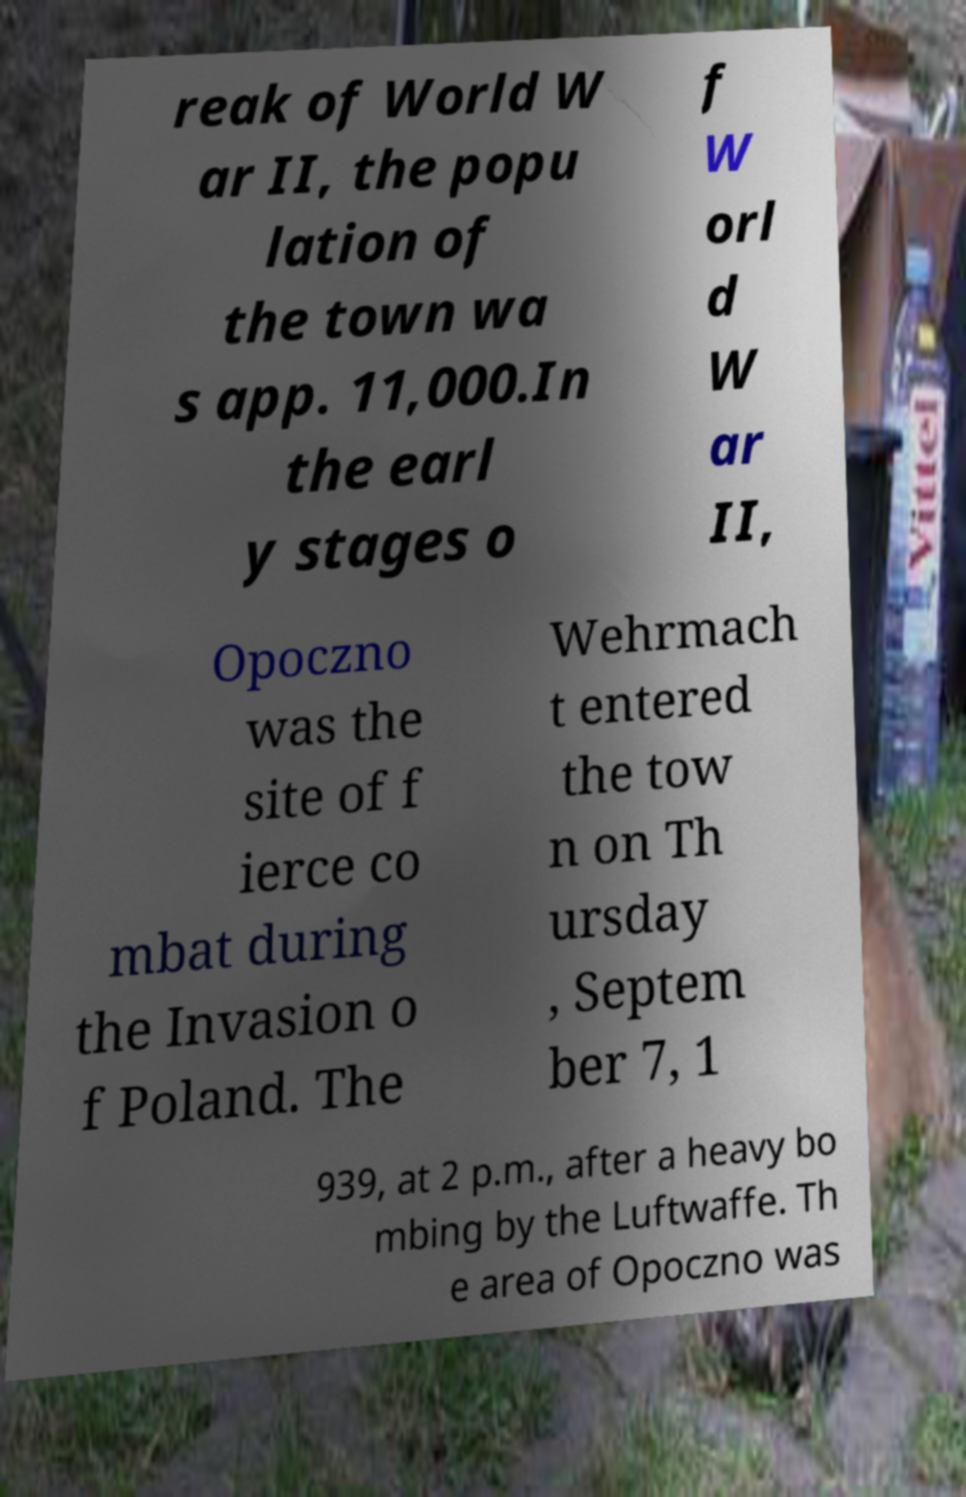Please identify and transcribe the text found in this image. reak of World W ar II, the popu lation of the town wa s app. 11,000.In the earl y stages o f W orl d W ar II, Opoczno was the site of f ierce co mbat during the Invasion o f Poland. The Wehrmach t entered the tow n on Th ursday , Septem ber 7, 1 939, at 2 p.m., after a heavy bo mbing by the Luftwaffe. Th e area of Opoczno was 